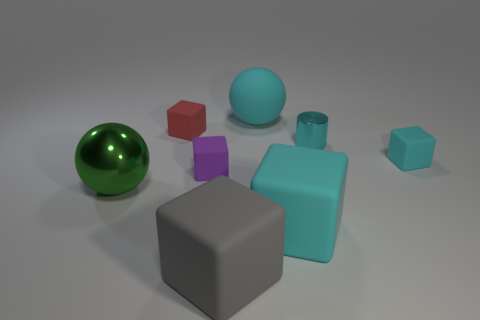Is there any other thing that is the same shape as the cyan metallic thing?
Your answer should be very brief. No. Is there anything else that is the same color as the large metallic object?
Ensure brevity in your answer.  No. Is the size of the sphere that is in front of the cyan ball the same as the metallic object that is right of the tiny red matte thing?
Your response must be concise. No. There is a big cyan thing that is in front of the red matte block that is to the right of the large metal thing; what shape is it?
Offer a very short reply. Cube. There is a red rubber cube; does it have the same size as the shiny object to the right of the tiny red rubber cube?
Offer a very short reply. Yes. How big is the ball to the left of the ball behind the big thing that is left of the gray object?
Your answer should be very brief. Large. What number of objects are balls that are to the right of the purple block or gray rubber things?
Ensure brevity in your answer.  2. There is a sphere that is on the left side of the purple rubber block; how many shiny cylinders are to the left of it?
Provide a short and direct response. 0. Is the number of purple matte blocks to the right of the green metallic sphere greater than the number of small cyan matte balls?
Provide a succinct answer. Yes. There is a rubber cube that is right of the large matte ball and behind the big green metal sphere; what size is it?
Your answer should be very brief. Small. 